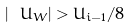<formula> <loc_0><loc_0><loc_500><loc_500>| \ U _ { W } | > U _ { i - 1 } / 8</formula> 